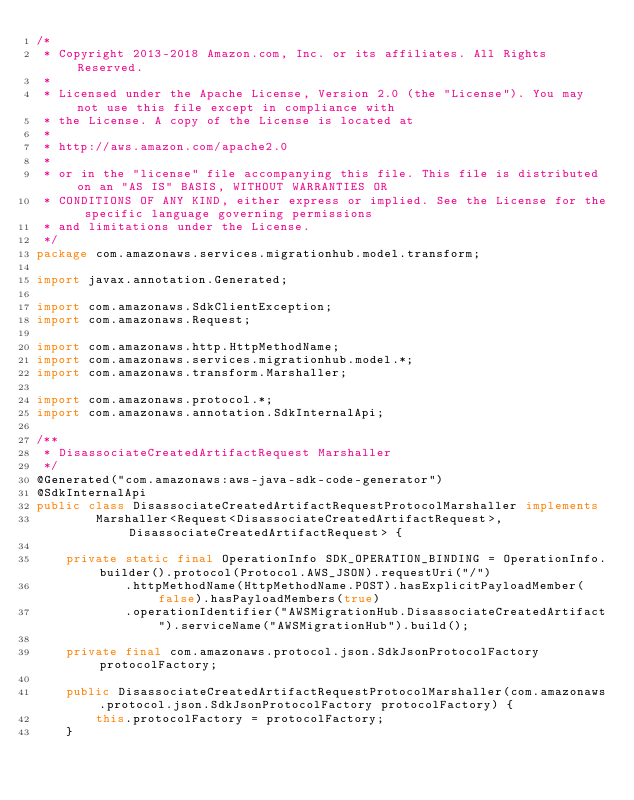<code> <loc_0><loc_0><loc_500><loc_500><_Java_>/*
 * Copyright 2013-2018 Amazon.com, Inc. or its affiliates. All Rights Reserved.
 * 
 * Licensed under the Apache License, Version 2.0 (the "License"). You may not use this file except in compliance with
 * the License. A copy of the License is located at
 * 
 * http://aws.amazon.com/apache2.0
 * 
 * or in the "license" file accompanying this file. This file is distributed on an "AS IS" BASIS, WITHOUT WARRANTIES OR
 * CONDITIONS OF ANY KIND, either express or implied. See the License for the specific language governing permissions
 * and limitations under the License.
 */
package com.amazonaws.services.migrationhub.model.transform;

import javax.annotation.Generated;

import com.amazonaws.SdkClientException;
import com.amazonaws.Request;

import com.amazonaws.http.HttpMethodName;
import com.amazonaws.services.migrationhub.model.*;
import com.amazonaws.transform.Marshaller;

import com.amazonaws.protocol.*;
import com.amazonaws.annotation.SdkInternalApi;

/**
 * DisassociateCreatedArtifactRequest Marshaller
 */
@Generated("com.amazonaws:aws-java-sdk-code-generator")
@SdkInternalApi
public class DisassociateCreatedArtifactRequestProtocolMarshaller implements
        Marshaller<Request<DisassociateCreatedArtifactRequest>, DisassociateCreatedArtifactRequest> {

    private static final OperationInfo SDK_OPERATION_BINDING = OperationInfo.builder().protocol(Protocol.AWS_JSON).requestUri("/")
            .httpMethodName(HttpMethodName.POST).hasExplicitPayloadMember(false).hasPayloadMembers(true)
            .operationIdentifier("AWSMigrationHub.DisassociateCreatedArtifact").serviceName("AWSMigrationHub").build();

    private final com.amazonaws.protocol.json.SdkJsonProtocolFactory protocolFactory;

    public DisassociateCreatedArtifactRequestProtocolMarshaller(com.amazonaws.protocol.json.SdkJsonProtocolFactory protocolFactory) {
        this.protocolFactory = protocolFactory;
    }
</code> 